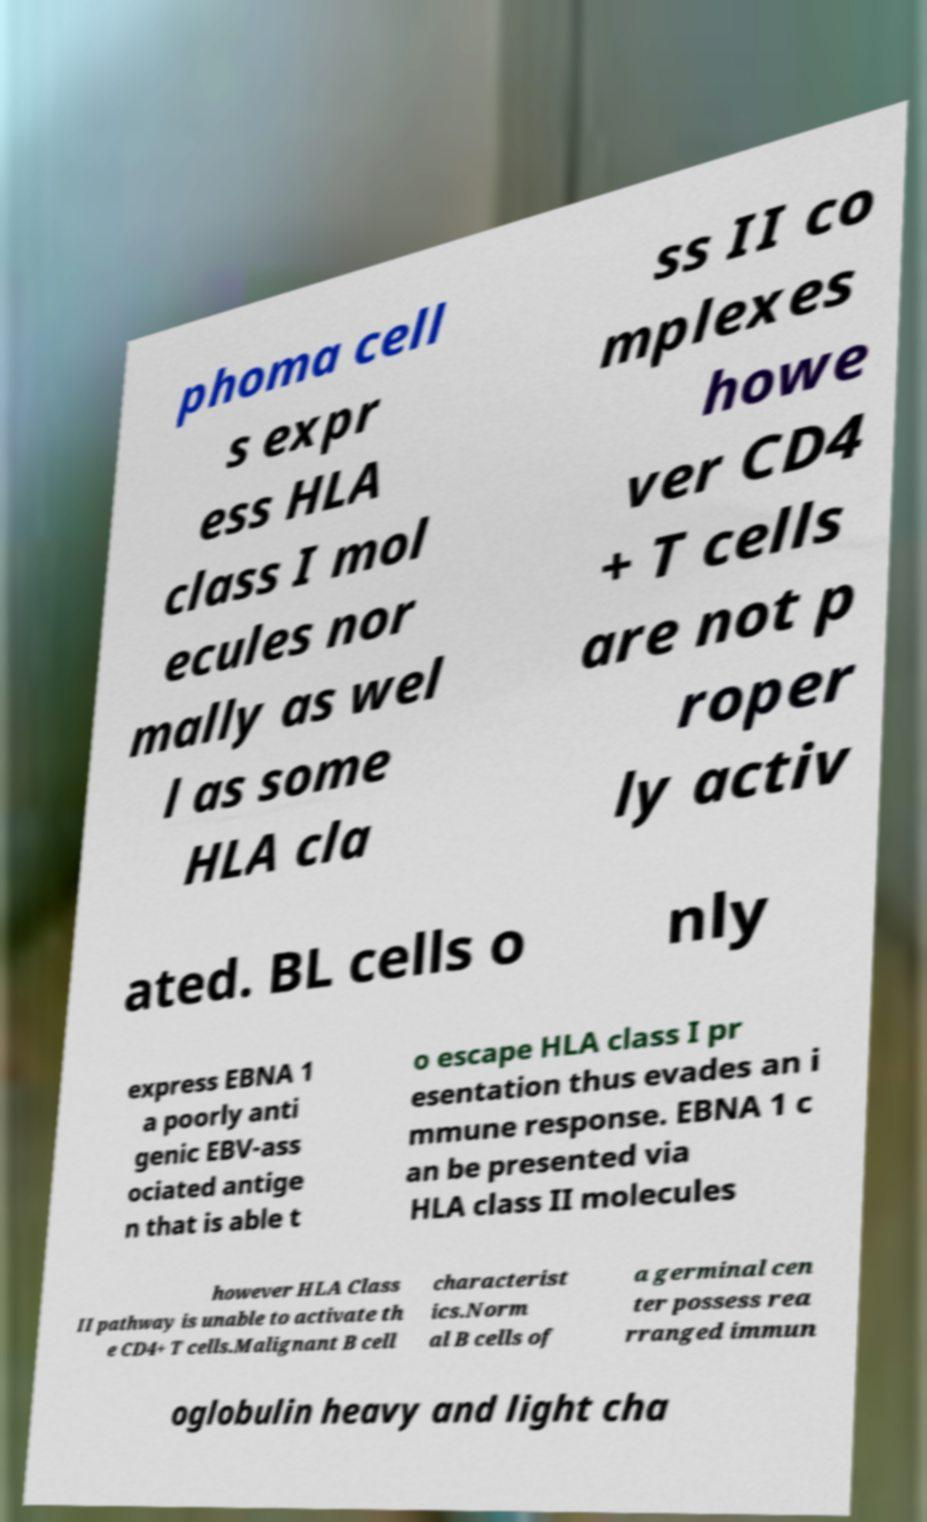Please read and relay the text visible in this image. What does it say? phoma cell s expr ess HLA class I mol ecules nor mally as wel l as some HLA cla ss II co mplexes howe ver CD4 + T cells are not p roper ly activ ated. BL cells o nly express EBNA 1 a poorly anti genic EBV-ass ociated antige n that is able t o escape HLA class I pr esentation thus evades an i mmune response. EBNA 1 c an be presented via HLA class II molecules however HLA Class II pathway is unable to activate th e CD4+ T cells.Malignant B cell characterist ics.Norm al B cells of a germinal cen ter possess rea rranged immun oglobulin heavy and light cha 